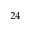Convert formula to latex. <formula><loc_0><loc_0><loc_500><loc_500>^ { 2 4 }</formula> 